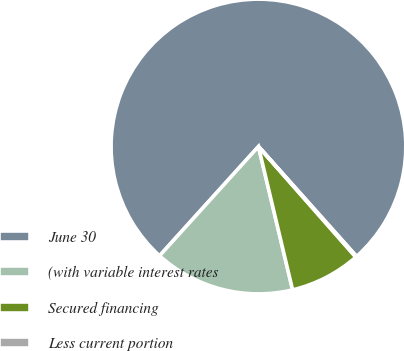Convert chart. <chart><loc_0><loc_0><loc_500><loc_500><pie_chart><fcel>June 30<fcel>(with variable interest rates<fcel>Secured financing<fcel>Less current portion<nl><fcel>76.7%<fcel>15.43%<fcel>7.77%<fcel>0.11%<nl></chart> 